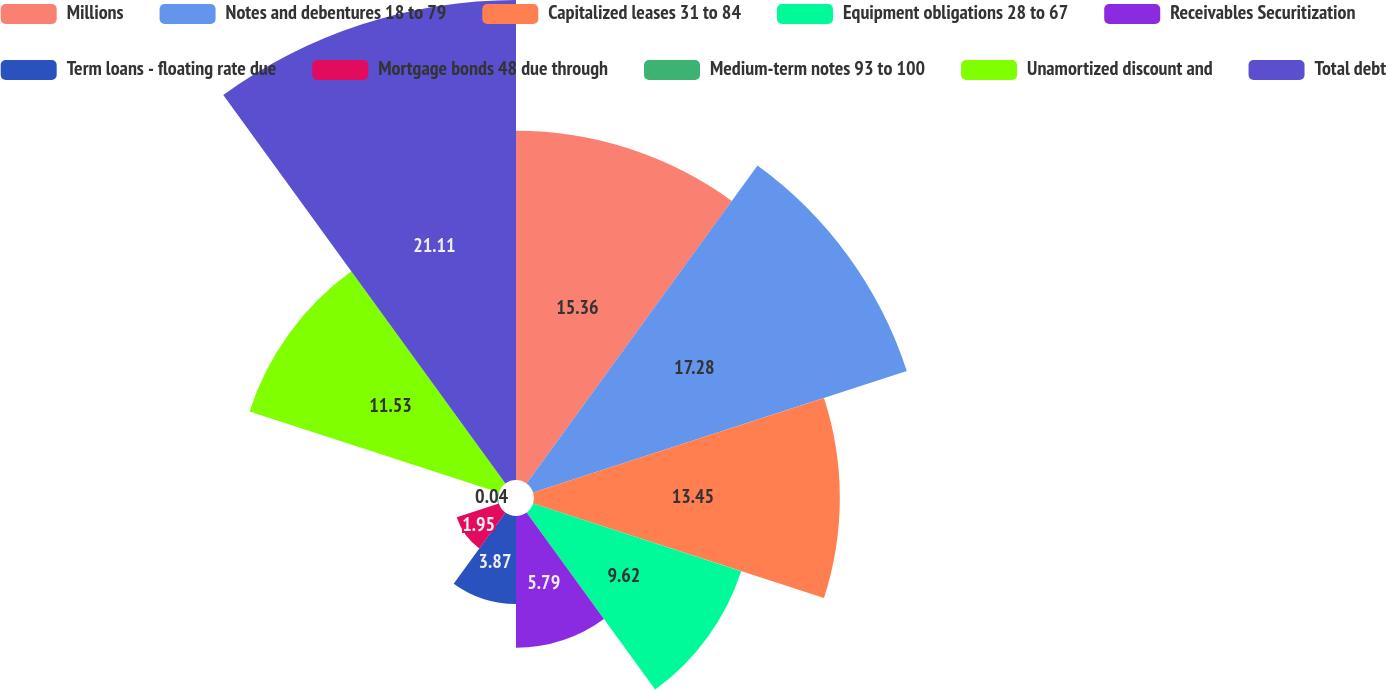<chart> <loc_0><loc_0><loc_500><loc_500><pie_chart><fcel>Millions<fcel>Notes and debentures 18 to 79<fcel>Capitalized leases 31 to 84<fcel>Equipment obligations 28 to 67<fcel>Receivables Securitization<fcel>Term loans - floating rate due<fcel>Mortgage bonds 48 due through<fcel>Medium-term notes 93 to 100<fcel>Unamortized discount and<fcel>Total debt<nl><fcel>15.36%<fcel>17.28%<fcel>13.45%<fcel>9.62%<fcel>5.79%<fcel>3.87%<fcel>1.95%<fcel>0.04%<fcel>11.53%<fcel>21.11%<nl></chart> 